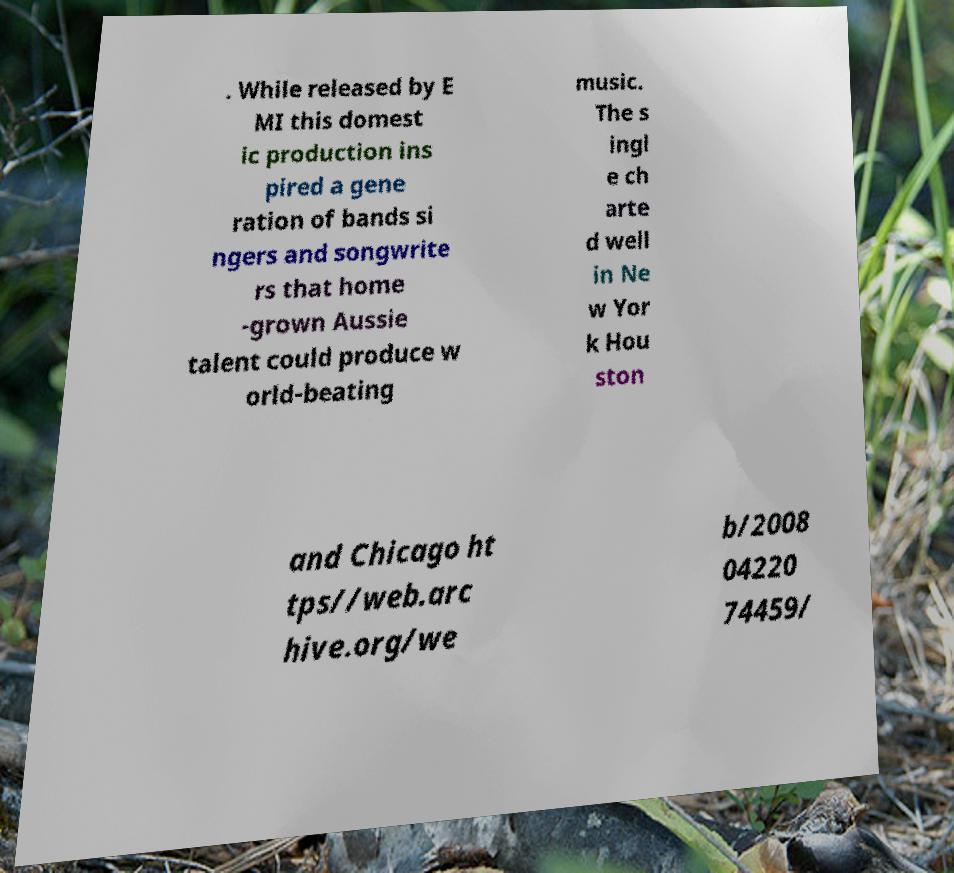There's text embedded in this image that I need extracted. Can you transcribe it verbatim? . While released by E MI this domest ic production ins pired a gene ration of bands si ngers and songwrite rs that home -grown Aussie talent could produce w orld-beating music. The s ingl e ch arte d well in Ne w Yor k Hou ston and Chicago ht tps//web.arc hive.org/we b/2008 04220 74459/ 